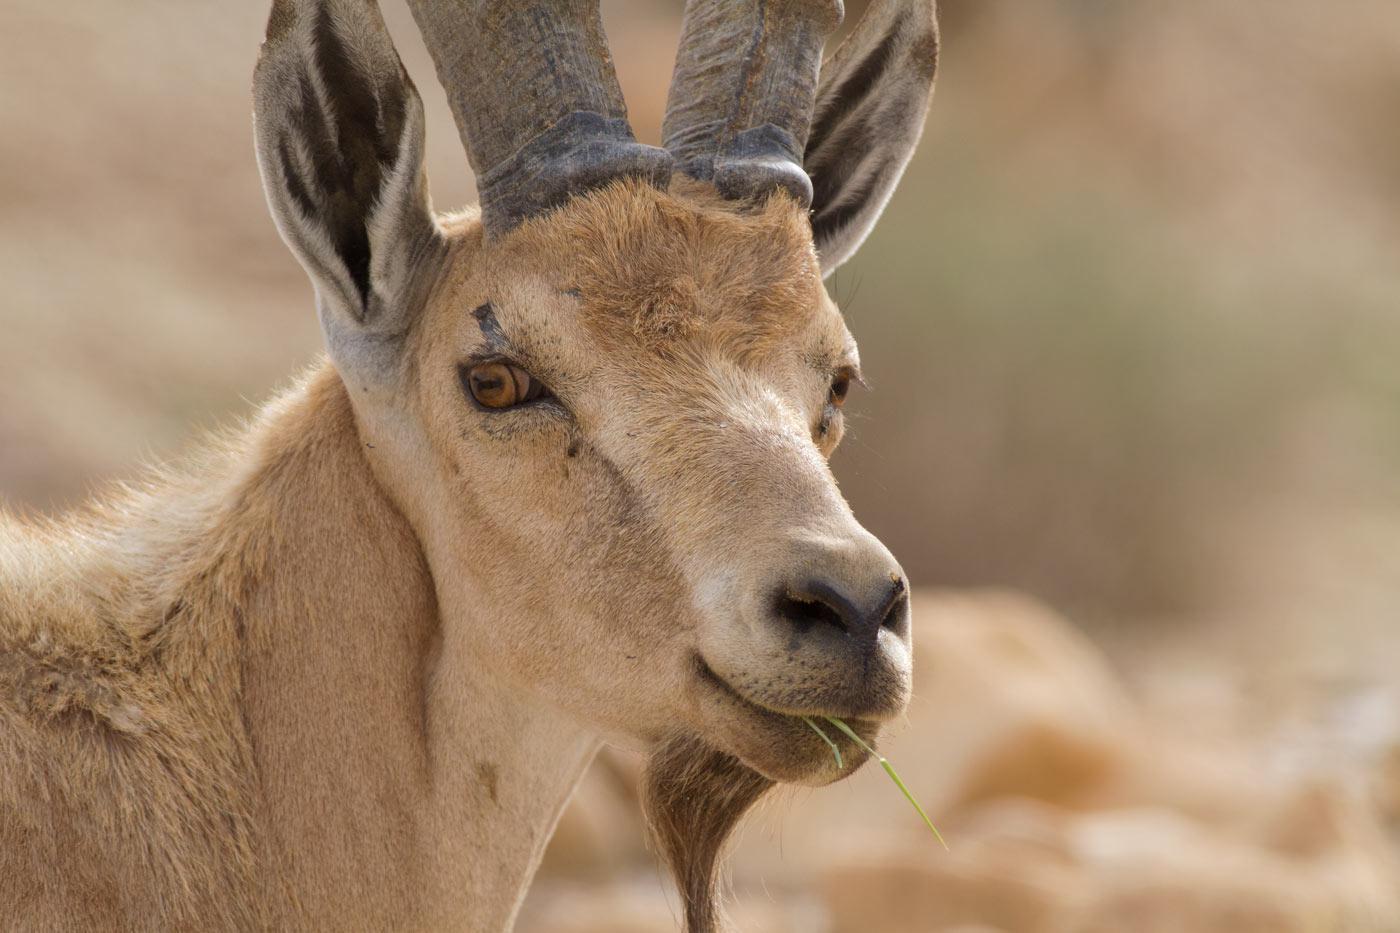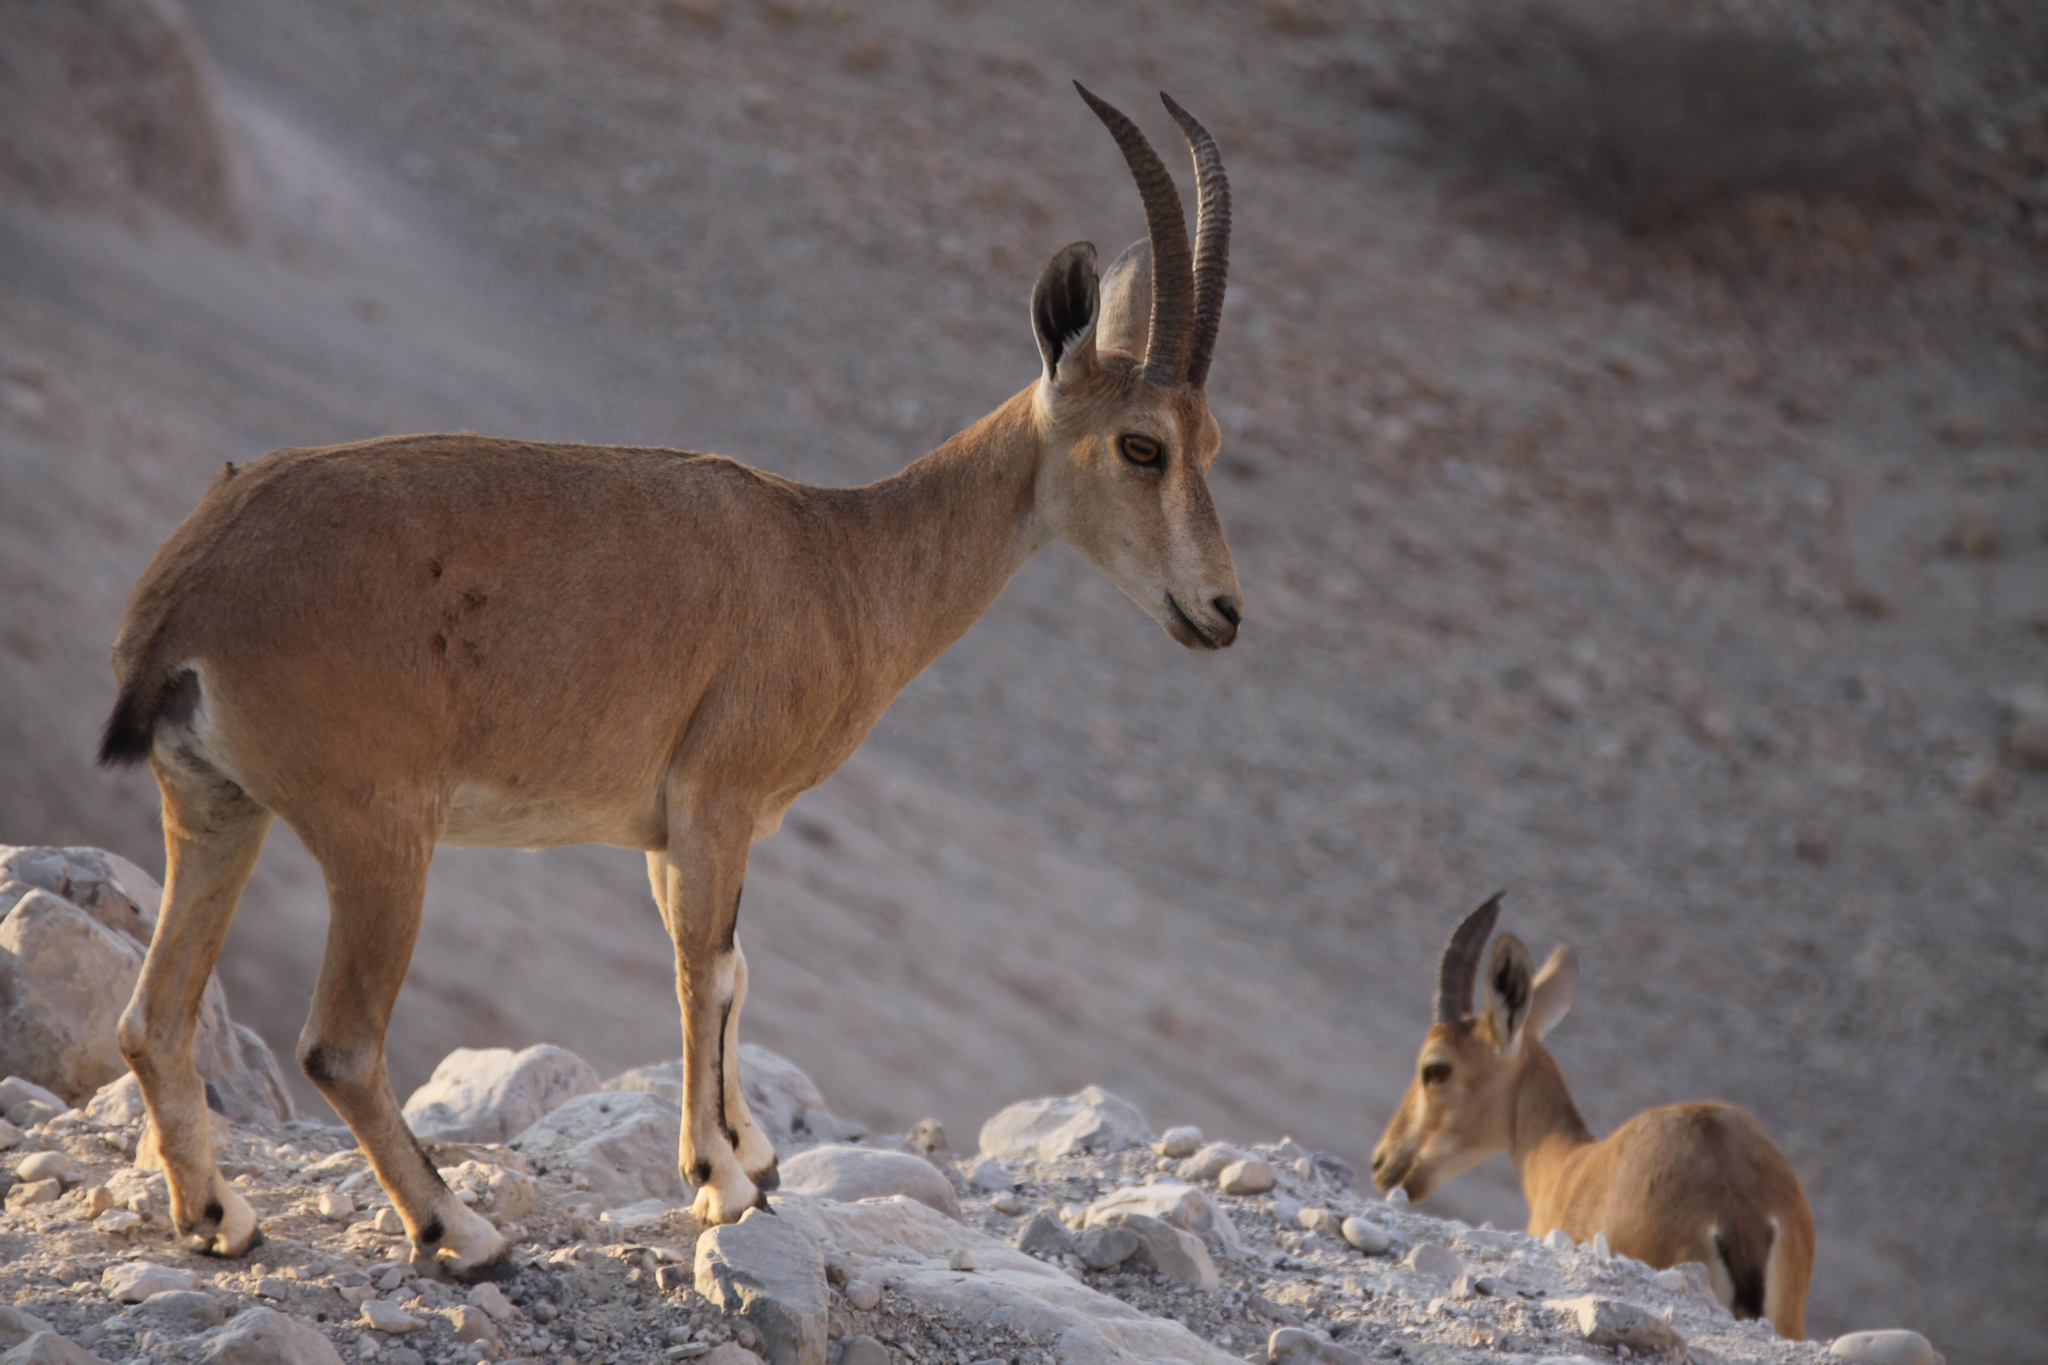The first image is the image on the left, the second image is the image on the right. Analyze the images presented: Is the assertion "The left and right image contains three horned goats." valid? Answer yes or no. Yes. The first image is the image on the left, the second image is the image on the right. Considering the images on both sides, is "In one of the images, the heads of two goats are visible." valid? Answer yes or no. Yes. 